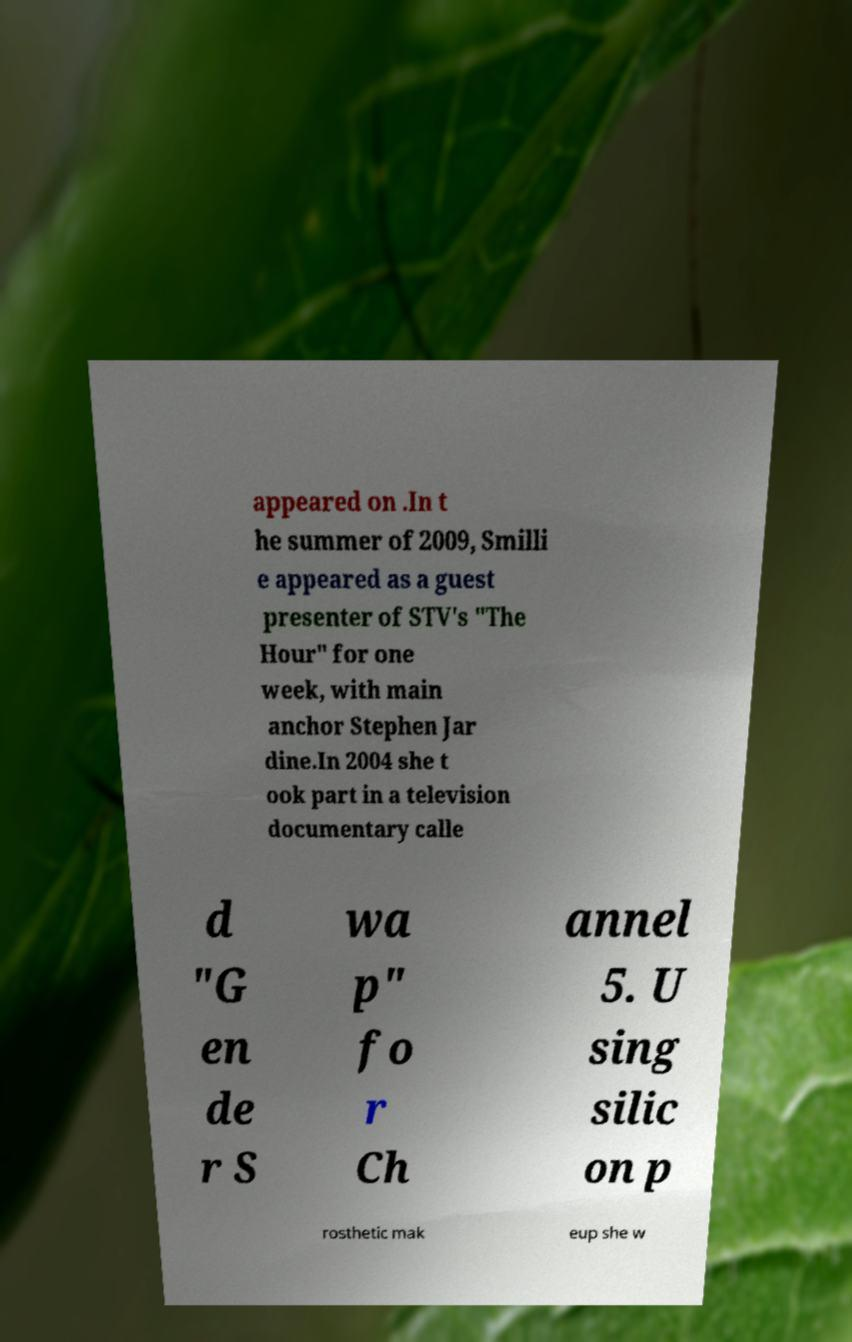There's text embedded in this image that I need extracted. Can you transcribe it verbatim? appeared on .In t he summer of 2009, Smilli e appeared as a guest presenter of STV's "The Hour" for one week, with main anchor Stephen Jar dine.In 2004 she t ook part in a television documentary calle d "G en de r S wa p" fo r Ch annel 5. U sing silic on p rosthetic mak eup she w 